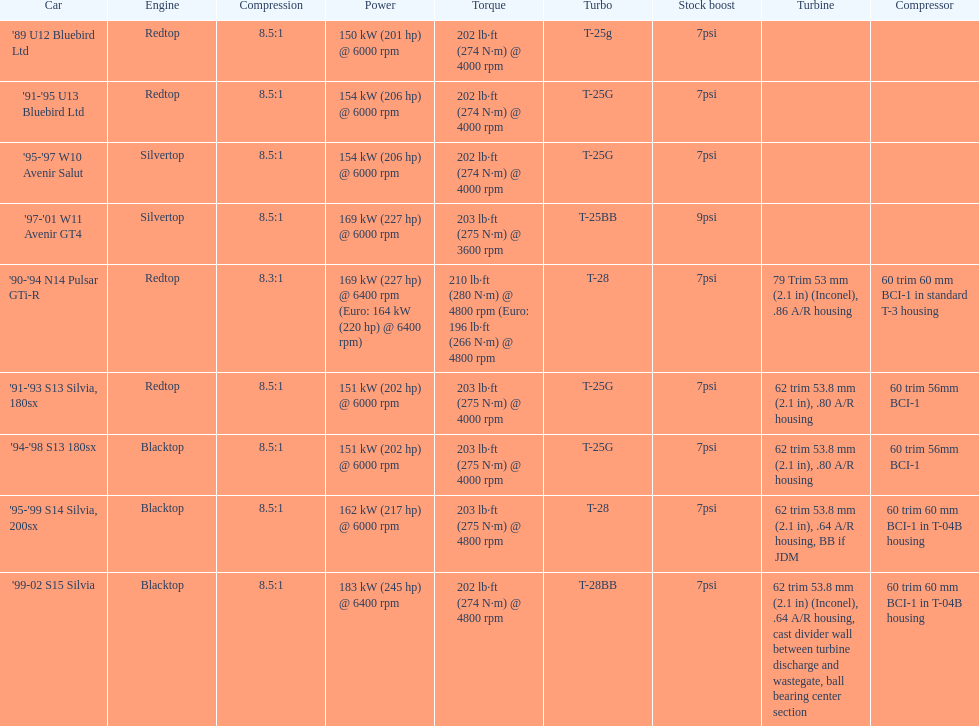Which motor(s) has the lowest amount of power? Redtop. 